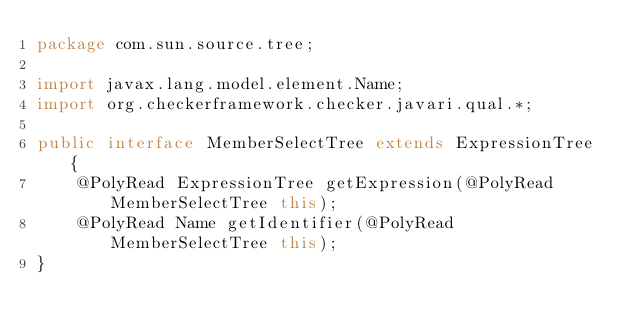Convert code to text. <code><loc_0><loc_0><loc_500><loc_500><_Java_>package com.sun.source.tree;

import javax.lang.model.element.Name;
import org.checkerframework.checker.javari.qual.*;

public interface MemberSelectTree extends ExpressionTree {
    @PolyRead ExpressionTree getExpression(@PolyRead MemberSelectTree this);
    @PolyRead Name getIdentifier(@PolyRead MemberSelectTree this);
}
</code> 